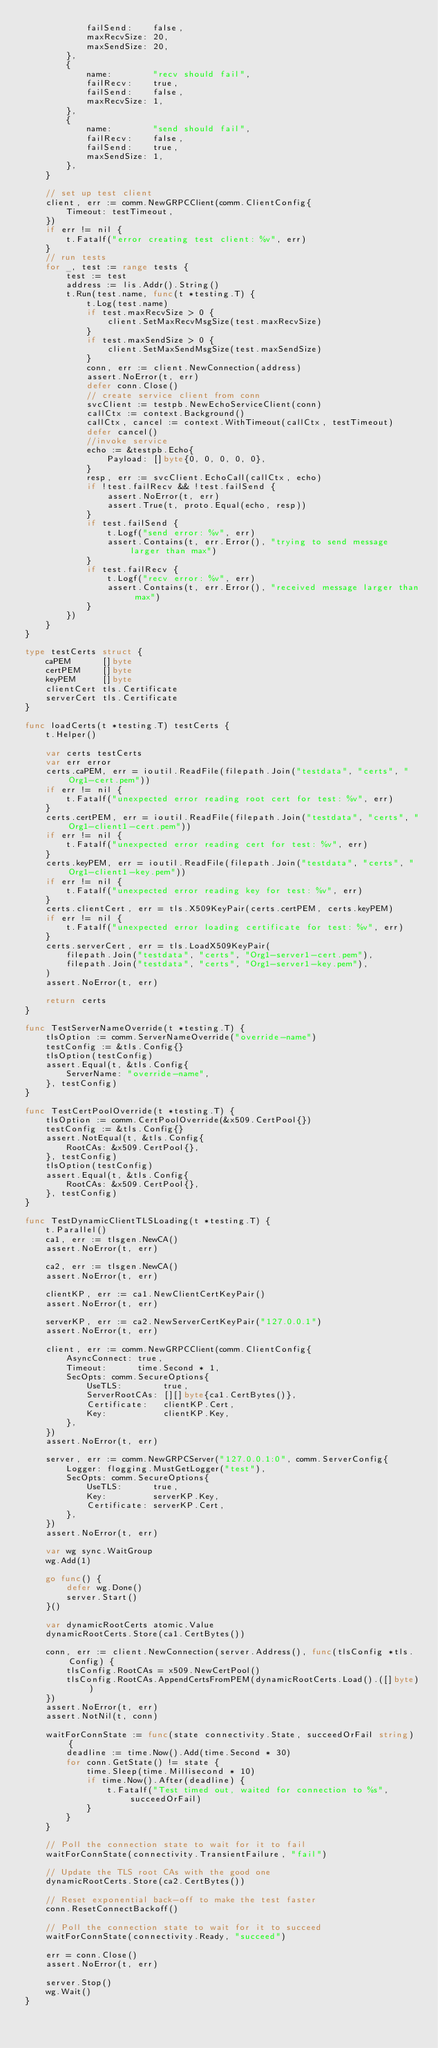Convert code to text. <code><loc_0><loc_0><loc_500><loc_500><_Go_>			failSend:    false,
			maxRecvSize: 20,
			maxSendSize: 20,
		},
		{
			name:        "recv should fail",
			failRecv:    true,
			failSend:    false,
			maxRecvSize: 1,
		},
		{
			name:        "send should fail",
			failRecv:    false,
			failSend:    true,
			maxSendSize: 1,
		},
	}

	// set up test client
	client, err := comm.NewGRPCClient(comm.ClientConfig{
		Timeout: testTimeout,
	})
	if err != nil {
		t.Fatalf("error creating test client: %v", err)
	}
	// run tests
	for _, test := range tests {
		test := test
		address := lis.Addr().String()
		t.Run(test.name, func(t *testing.T) {
			t.Log(test.name)
			if test.maxRecvSize > 0 {
				client.SetMaxRecvMsgSize(test.maxRecvSize)
			}
			if test.maxSendSize > 0 {
				client.SetMaxSendMsgSize(test.maxSendSize)
			}
			conn, err := client.NewConnection(address)
			assert.NoError(t, err)
			defer conn.Close()
			// create service client from conn
			svcClient := testpb.NewEchoServiceClient(conn)
			callCtx := context.Background()
			callCtx, cancel := context.WithTimeout(callCtx, testTimeout)
			defer cancel()
			//invoke service
			echo := &testpb.Echo{
				Payload: []byte{0, 0, 0, 0, 0},
			}
			resp, err := svcClient.EchoCall(callCtx, echo)
			if !test.failRecv && !test.failSend {
				assert.NoError(t, err)
				assert.True(t, proto.Equal(echo, resp))
			}
			if test.failSend {
				t.Logf("send error: %v", err)
				assert.Contains(t, err.Error(), "trying to send message larger than max")
			}
			if test.failRecv {
				t.Logf("recv error: %v", err)
				assert.Contains(t, err.Error(), "received message larger than max")
			}
		})
	}
}

type testCerts struct {
	caPEM      []byte
	certPEM    []byte
	keyPEM     []byte
	clientCert tls.Certificate
	serverCert tls.Certificate
}

func loadCerts(t *testing.T) testCerts {
	t.Helper()

	var certs testCerts
	var err error
	certs.caPEM, err = ioutil.ReadFile(filepath.Join("testdata", "certs", "Org1-cert.pem"))
	if err != nil {
		t.Fatalf("unexpected error reading root cert for test: %v", err)
	}
	certs.certPEM, err = ioutil.ReadFile(filepath.Join("testdata", "certs", "Org1-client1-cert.pem"))
	if err != nil {
		t.Fatalf("unexpected error reading cert for test: %v", err)
	}
	certs.keyPEM, err = ioutil.ReadFile(filepath.Join("testdata", "certs", "Org1-client1-key.pem"))
	if err != nil {
		t.Fatalf("unexpected error reading key for test: %v", err)
	}
	certs.clientCert, err = tls.X509KeyPair(certs.certPEM, certs.keyPEM)
	if err != nil {
		t.Fatalf("unexpected error loading certificate for test: %v", err)
	}
	certs.serverCert, err = tls.LoadX509KeyPair(
		filepath.Join("testdata", "certs", "Org1-server1-cert.pem"),
		filepath.Join("testdata", "certs", "Org1-server1-key.pem"),
	)
	assert.NoError(t, err)

	return certs
}

func TestServerNameOverride(t *testing.T) {
	tlsOption := comm.ServerNameOverride("override-name")
	testConfig := &tls.Config{}
	tlsOption(testConfig)
	assert.Equal(t, &tls.Config{
		ServerName: "override-name",
	}, testConfig)
}

func TestCertPoolOverride(t *testing.T) {
	tlsOption := comm.CertPoolOverride(&x509.CertPool{})
	testConfig := &tls.Config{}
	assert.NotEqual(t, &tls.Config{
		RootCAs: &x509.CertPool{},
	}, testConfig)
	tlsOption(testConfig)
	assert.Equal(t, &tls.Config{
		RootCAs: &x509.CertPool{},
	}, testConfig)
}

func TestDynamicClientTLSLoading(t *testing.T) {
	t.Parallel()
	ca1, err := tlsgen.NewCA()
	assert.NoError(t, err)

	ca2, err := tlsgen.NewCA()
	assert.NoError(t, err)

	clientKP, err := ca1.NewClientCertKeyPair()
	assert.NoError(t, err)

	serverKP, err := ca2.NewServerCertKeyPair("127.0.0.1")
	assert.NoError(t, err)

	client, err := comm.NewGRPCClient(comm.ClientConfig{
		AsyncConnect: true,
		Timeout:      time.Second * 1,
		SecOpts: comm.SecureOptions{
			UseTLS:        true,
			ServerRootCAs: [][]byte{ca1.CertBytes()},
			Certificate:   clientKP.Cert,
			Key:           clientKP.Key,
		},
	})
	assert.NoError(t, err)

	server, err := comm.NewGRPCServer("127.0.0.1:0", comm.ServerConfig{
		Logger: flogging.MustGetLogger("test"),
		SecOpts: comm.SecureOptions{
			UseTLS:      true,
			Key:         serverKP.Key,
			Certificate: serverKP.Cert,
		},
	})
	assert.NoError(t, err)

	var wg sync.WaitGroup
	wg.Add(1)

	go func() {
		defer wg.Done()
		server.Start()
	}()

	var dynamicRootCerts atomic.Value
	dynamicRootCerts.Store(ca1.CertBytes())

	conn, err := client.NewConnection(server.Address(), func(tlsConfig *tls.Config) {
		tlsConfig.RootCAs = x509.NewCertPool()
		tlsConfig.RootCAs.AppendCertsFromPEM(dynamicRootCerts.Load().([]byte))
	})
	assert.NoError(t, err)
	assert.NotNil(t, conn)

	waitForConnState := func(state connectivity.State, succeedOrFail string) {
		deadline := time.Now().Add(time.Second * 30)
		for conn.GetState() != state {
			time.Sleep(time.Millisecond * 10)
			if time.Now().After(deadline) {
				t.Fatalf("Test timed out, waited for connection to %s", succeedOrFail)
			}
		}
	}

	// Poll the connection state to wait for it to fail
	waitForConnState(connectivity.TransientFailure, "fail")

	// Update the TLS root CAs with the good one
	dynamicRootCerts.Store(ca2.CertBytes())

	// Reset exponential back-off to make the test faster
	conn.ResetConnectBackoff()

	// Poll the connection state to wait for it to succeed
	waitForConnState(connectivity.Ready, "succeed")

	err = conn.Close()
	assert.NoError(t, err)

	server.Stop()
	wg.Wait()
}
</code> 